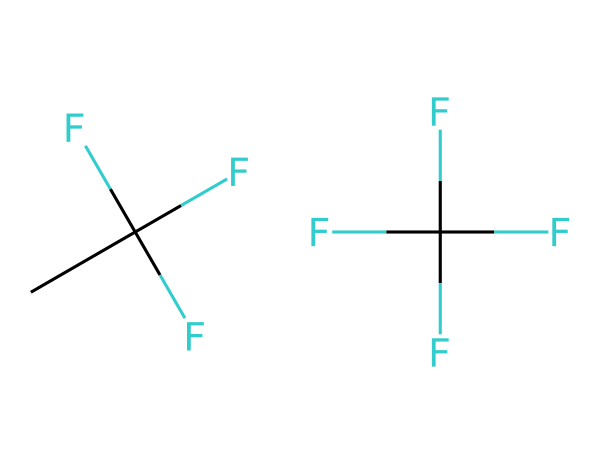How many carbon atoms are in R-410A? By analyzing the SMILES representation, "CC(F)(F)F" indicates that there are 2 carbon atoms in the first part. The second part "C(F)(F)(F)F" shows another carbon atom, making a total of 3 carbon atoms in R-410A.
Answer: 3 How many fluorine atoms are present in R-410A? The first component "CC(F)(F)F" has 3 fluorine atoms, and the second component "C(F)(F)(F)F" has 4 fluorine atoms. Adding them together, we get a total of 7 fluorine atoms in R-410A.
Answer: 7 What is the total number of atoms in R-410A? To calculate the total number of atoms, we count the carbon (3), hydrogen (2 from the first part), and fluorine (7) atoms. This sums up to 3 + 2 + 7 = 12 total atoms in R-410A.
Answer: 12 What type of chemical compound is R-410A? R-410A is identified as a hydrochlorofluorocarbon (HCFC) based on its composition of carbon, hydrogen, and fluorine atoms along with the absence of chlorine.
Answer: HCFC Why is R-410A considered environmentally friendly compared to older refrigerants? R-410A has a lower ozone depletion potential than older refrigerants like R-22, thanks to its molecular structure which does not include chlorine atoms that are harmful to the ozone layer.
Answer: lower ozone depletion potential What characteristic of R-410A leads to its efficiency in cooling applications? The presence of multiple fluorine atoms enhances the chemical stability and efficiency in heat exchange processes, which contributes to its effectiveness in air conditioning systems.
Answer: multiple fluorine atoms What is the molecular formula of R-410A? By assembling the total counts of carbon (C), hydrogen (H), and fluorine (F) atoms from the previous questions, R-410A's molecular formula can be written as C3H2F7.
Answer: C3H2F7 